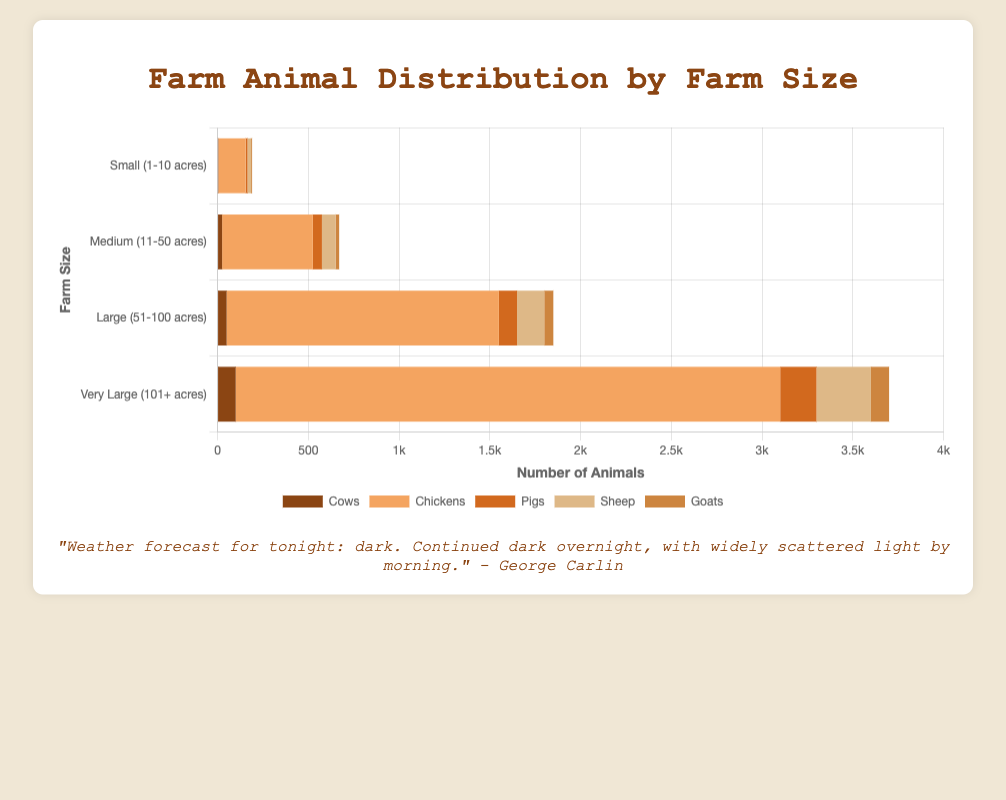What is the total number of cows on large farms? Look at the "Large (51-100 acres)" bar for cows. The value is 50.
Answer: 50 How many more chickens are there on medium farms compared to small farms? Check the values for chickens: 500 on medium farms and 150 on small farms. Subtract the small farm value from the medium farm value: 500 - 150 = 350.
Answer: 350 Which farm size has the highest number of goats overall? Identify the bar for goats in each farm size category. The "Very Large (101+ acres)" category has the highest value of 100.
Answer: Very Large (101+ acres) What is the combined number of sheep on small and medium farms? Add the number of sheep on small farms (20) to the number of sheep on medium farms (75). 20 + 75 = 95.
Answer: 95 Which animal type has the most significant overall presence on very large farms? Compare the numerical values for each animal type on the "Very Large (101+ acres)" farm size. Chickens have the highest number with 3000.
Answer: Chickens What is the difference in the number of pigs between large and very large farms? Look at the number of pigs in the large (100) and very large (200) farm categories. Subtract 100 from 200. 200 - 100 = 100.
Answer: 100 How many times more goats are there on very large farms compared to small farms? There are 100 goats on very large farms and 5 goats on small farms. Divide 100 by 5. 100 / 5 = 20.
Answer: 20 What is the ratio of sheep to cows on medium farms? On medium farms, there are 75 sheep and 25 cows. The ratio is calculated as 75 divided by 25. 75 / 25 = 3.
Answer: 3 Which farm size category has the least total number of animals? Sum the numbers of animals for each farm size category and compare. Small farms have the least total: 5 (cows) + 150 (chickens) + 10 (pigs) + 20 (sheep) + 5 (goats) = 190.
Answer: Small (1-10 acres) What's the average number of pigs across all farm sizes? Add the number of pigs for all sizes then divide by the number of categories: (10 + 50 + 100 + 200) / 4 = 360 / 4.
Answer: 90 